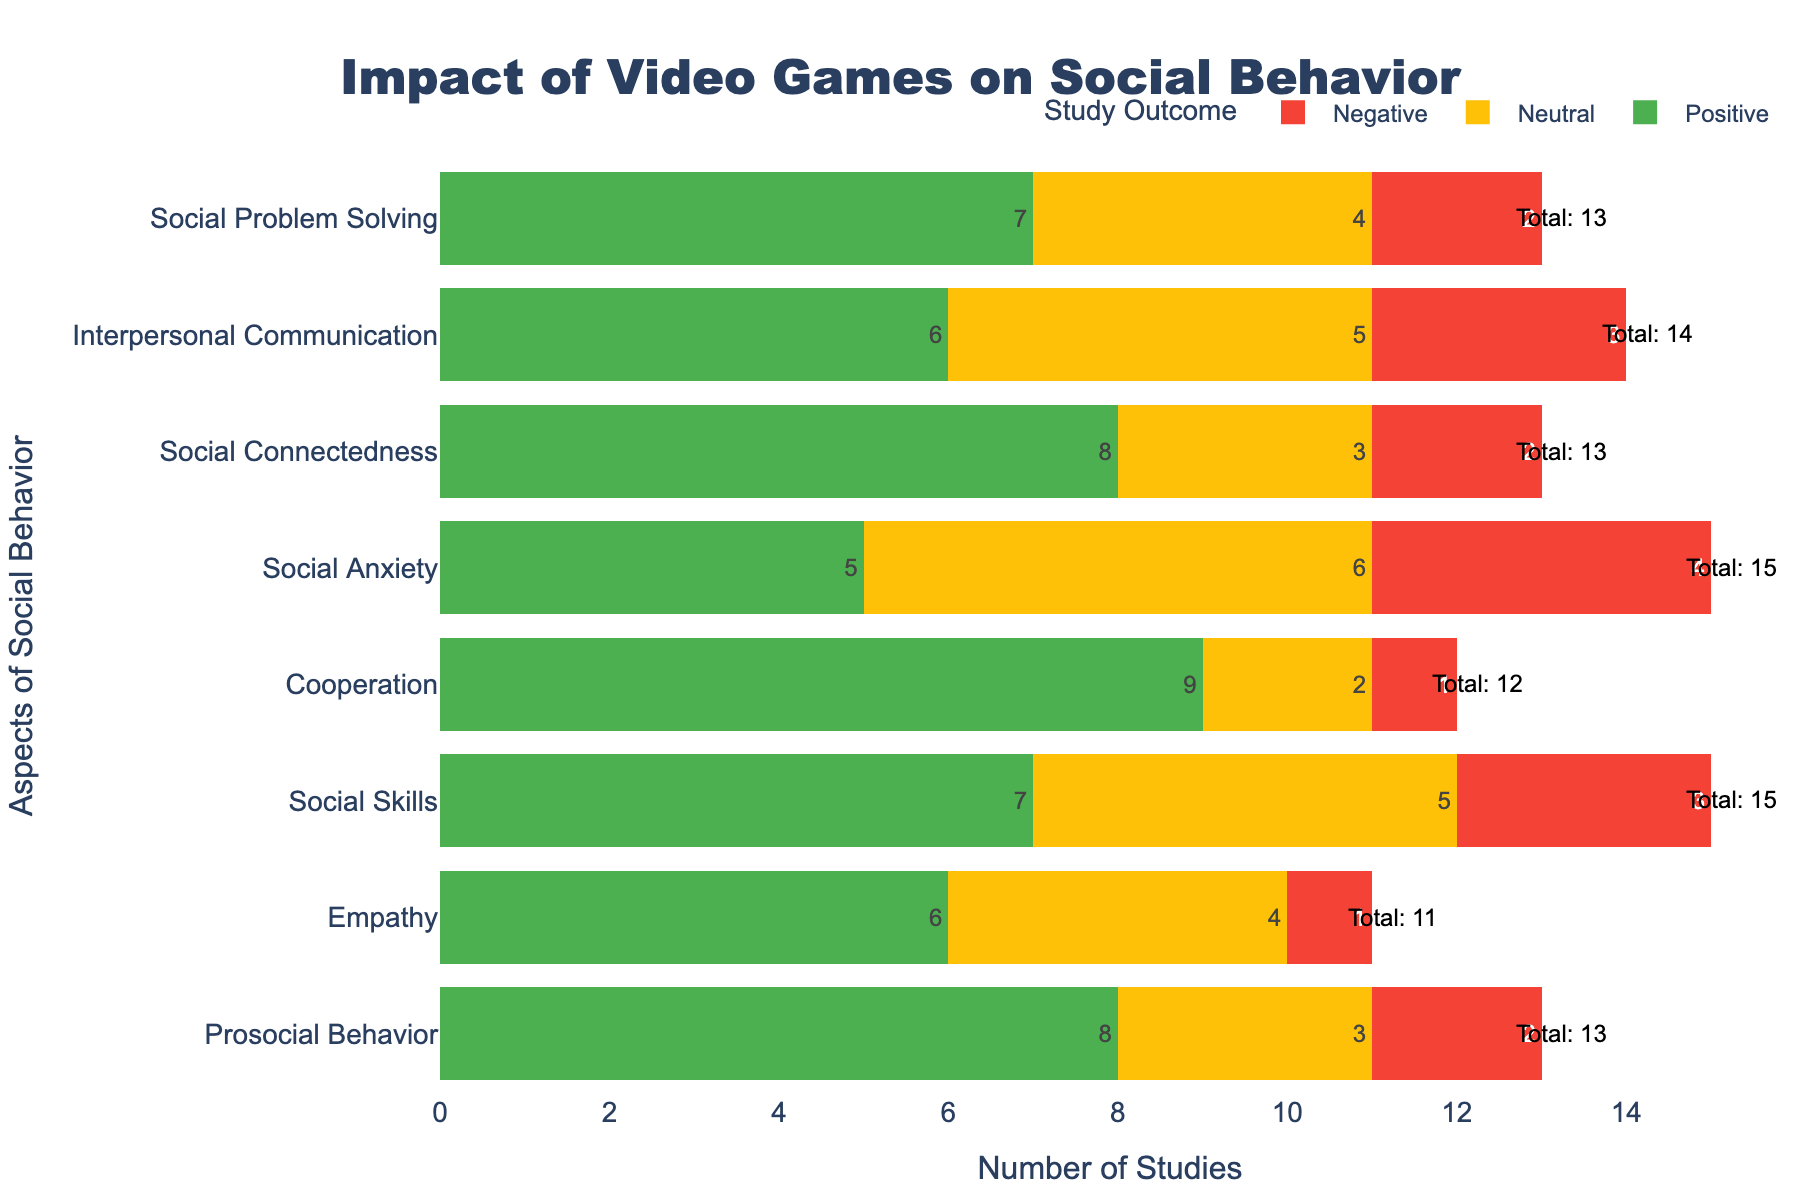Which aspect of social behavior has the highest number of positive outcomes in the studies? We look for the highest number in the 'Positive' category. Cooperation has 9 positive outcomes, which is the highest.
Answer: Cooperation How many total studies focus on empathy? We need to add up the numbers for positive, neutral, and negative outcomes for empathy: 6 + 4 + 1 = 11.
Answer: 11 Which category has more neutral studies, social connectedness or social anxiety? We compare the number of neutral studies in social connectedness (3) and social anxiety (6). Social anxiety has more.
Answer: Social anxiety What is the total number of studies conducted on cooperation? Sum the positive, neutral, and negative studies for cooperation: 9 + 2 + 1 = 12.
Answer: 12 In which area of social behavior is there the least number of negative studies? We look for the smallest number in the 'Negative' category. Both Cooperation and Empathy have 1 negative study, which is the least.
Answer: Cooperation, Empathy What is the combined total of positive studies in prosocial behavior and social skills? Add the positive studies in prosocial behavior (8) and social skills (7): 8 + 7 = 15.
Answer: 15 Is the number of positive studies on interpersonal communication greater than the number of neutral studies on social problem solving? Compare positive studies in interpersonal communication (6) to neutral studies in social problem solving (4). Yes, 6 is greater than 4.
Answer: Yes How many more positive studies are there for cooperation compared to social anxiety? Subtract positive studies in social anxiety (5) from cooperation (9): 9 - 5 = 4.
Answer: 4 Which aspect of social behavior has the most balanced (equal or close to equal) distribution among positive, neutral, and negative outcomes? We look for the aspect where the numbers in 'Positive,' 'Neutral,' and 'Negative' categories are most similar. Social anxiety has 5 positive, 6 neutral, and 4 negative, which are closest in number.
Answer: Social anxiety 